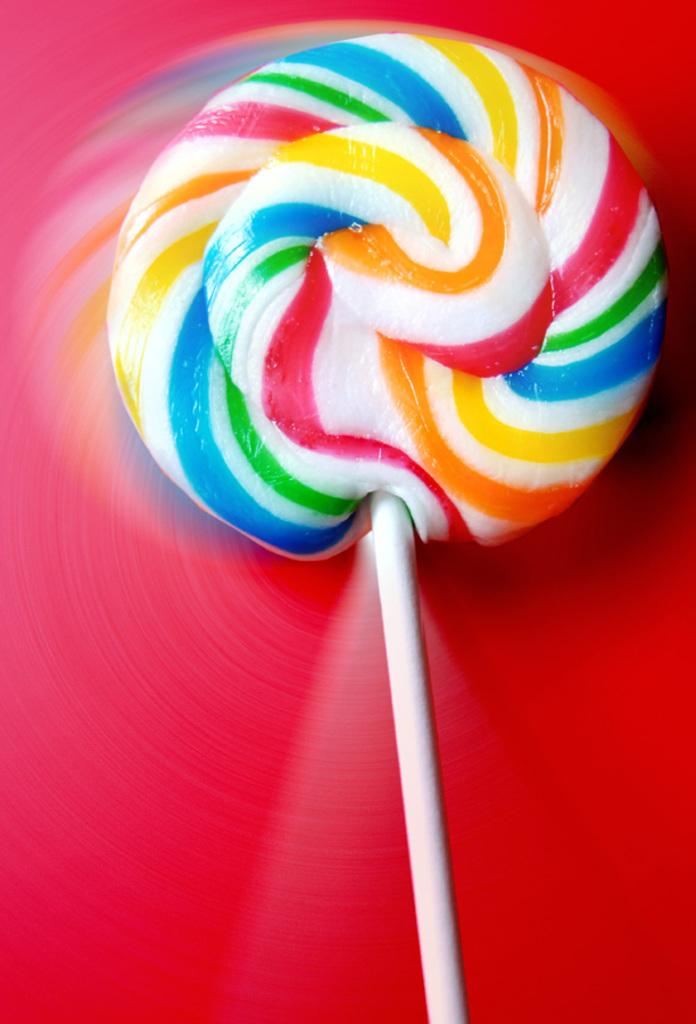What type of food is present in the image? There is a candy in the image. Can you describe the appearance of the candy? The candy has different colors. What type of judge is depicted reading a book in the image? There is no judge or book present in the image; it only features a candy with different colors. 